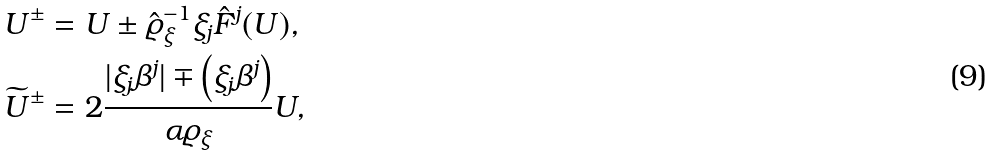Convert formula to latex. <formula><loc_0><loc_0><loc_500><loc_500>& { U } ^ { \pm } = { U } \pm { \hat { \varrho } _ { \xi } } ^ { - 1 } \xi _ { j } { { \hat { F } ^ { j } ( { U } ) } } , \\ & \widetilde { U } ^ { \pm } = 2 \frac { | \xi _ { j } \beta ^ { j } | \mp \left ( \xi _ { j } \beta ^ { j } \right ) } { \alpha \varrho _ { \xi } } { U } ,</formula> 